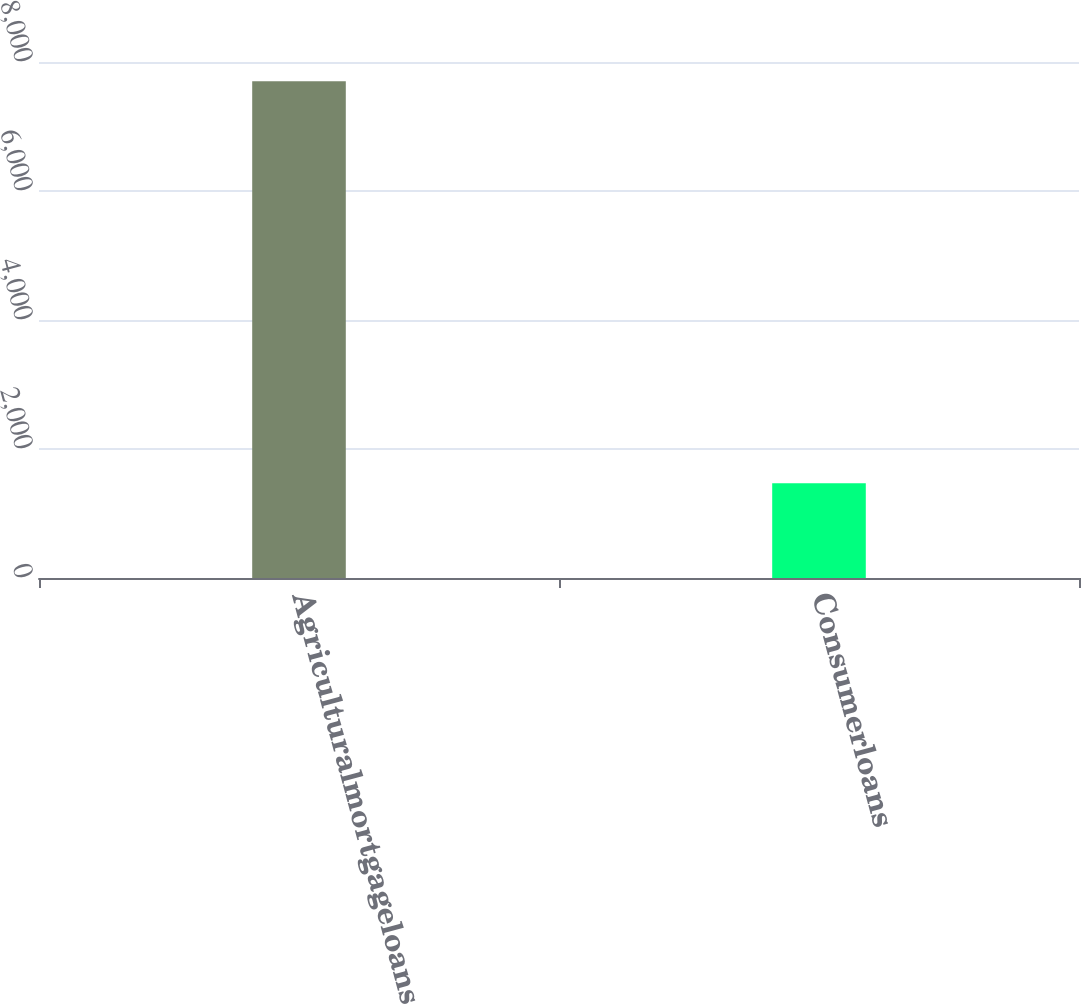Convert chart to OTSL. <chart><loc_0><loc_0><loc_500><loc_500><bar_chart><fcel>Agriculturalmortgageloans<fcel>Consumerloans<nl><fcel>7700<fcel>1468<nl></chart> 